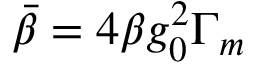<formula> <loc_0><loc_0><loc_500><loc_500>\ B a r { \beta } = 4 \beta g _ { 0 } ^ { 2 } \Gamma _ { m }</formula> 